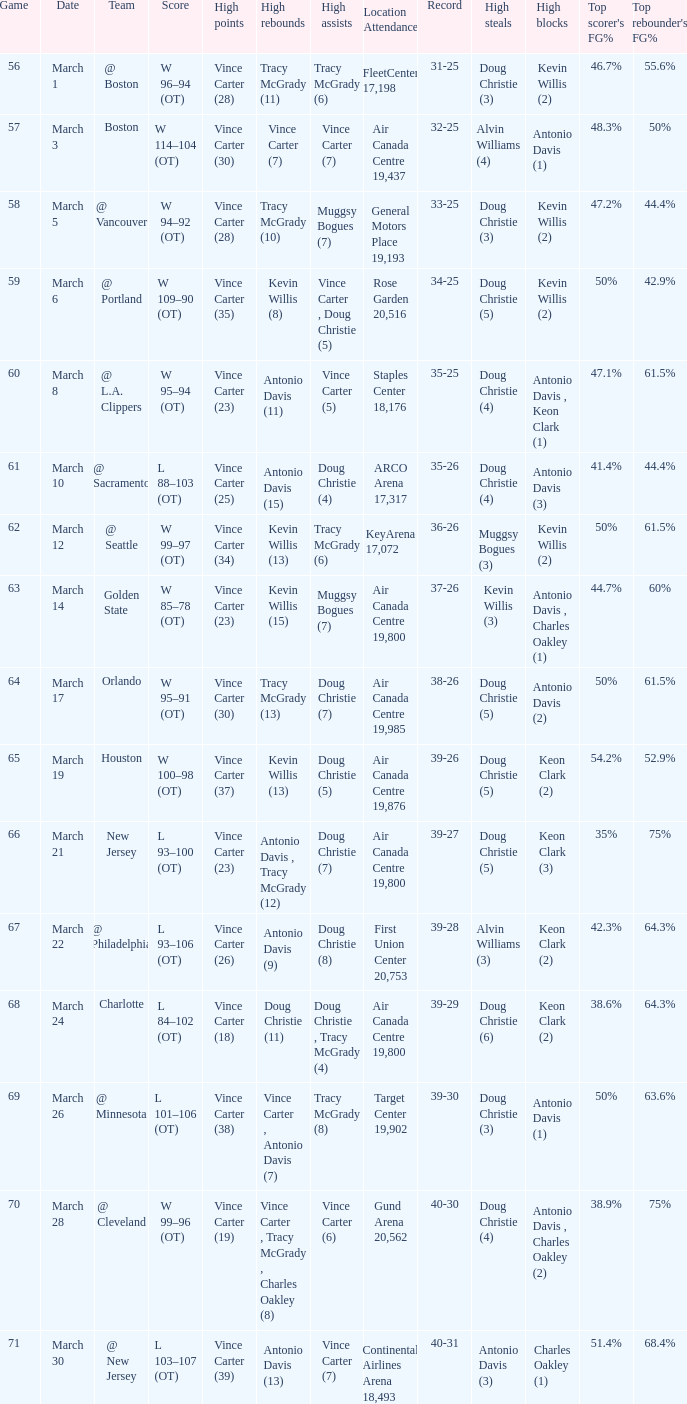Who was the high rebounder against charlotte? Doug Christie (11). 